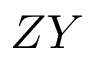<formula> <loc_0><loc_0><loc_500><loc_500>Z Y</formula> 